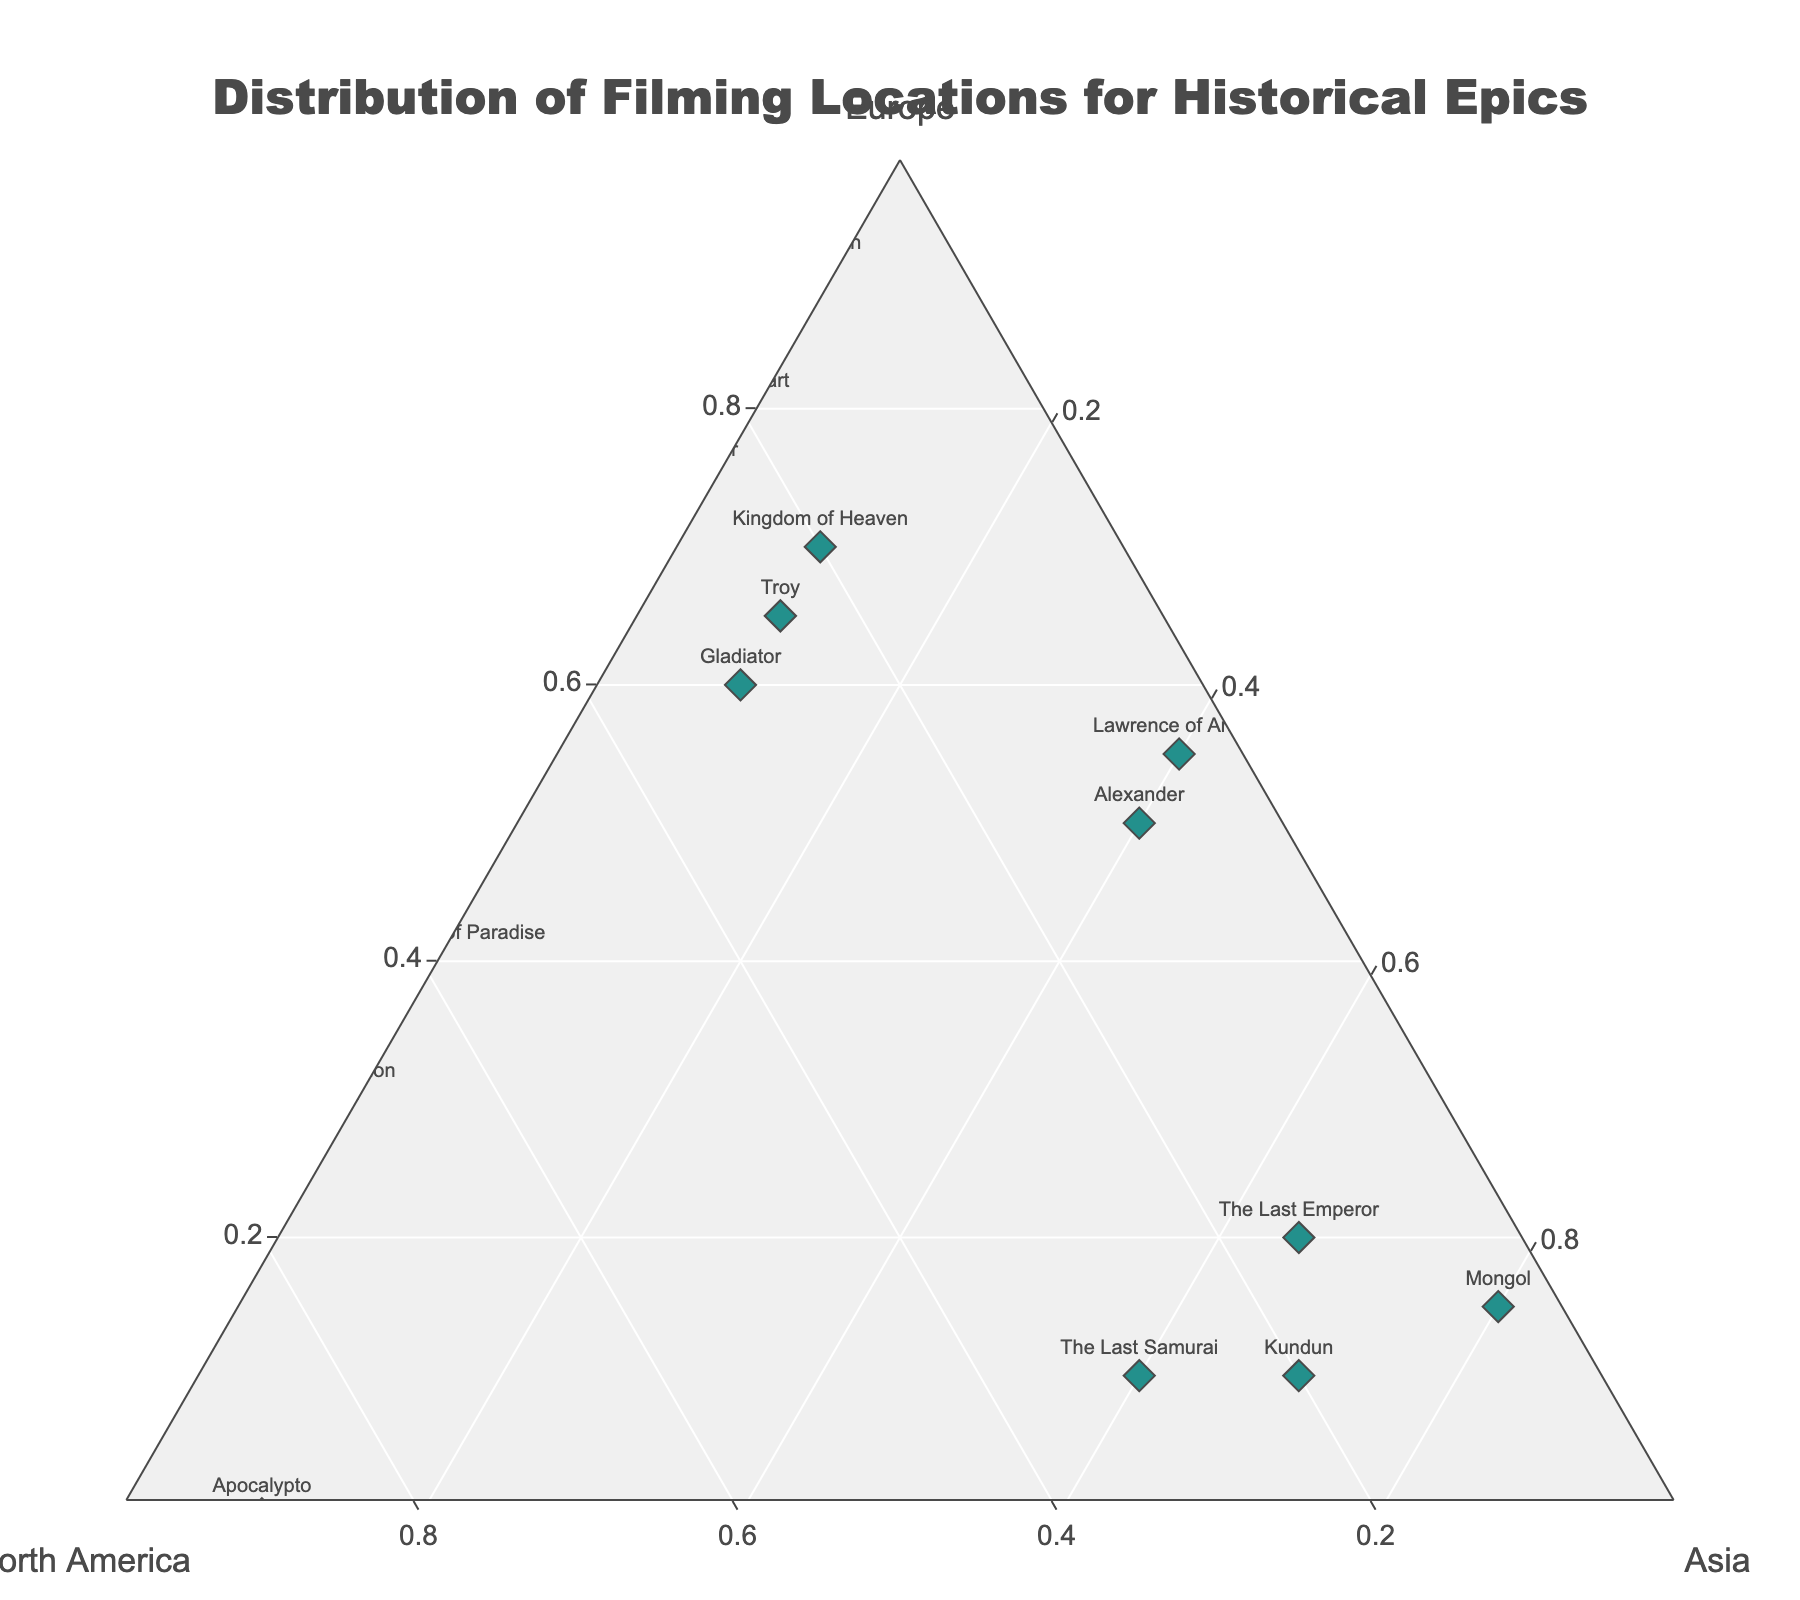what is the title of the plot? The title of the plot is prominently displayed at the top center of the figure.
Answer: "Distribution of Filming Locations for Historical Epics" How many movies have over 50% of their filming locations in Europe? Count the points located more than halfway along the Europe axis in the ternary plot.
Answer: 7 Which movie has the highest percentage of filming locations in North America? Identify the point furthest along the North America axis.
Answer: Apocalypto What percentage of Braveheart's filming locations are in North America? Locate Braveheart in the plot and check its position relative to the North America axis.
Answer: 20% Which movie has a more balanced distribution across all three continents, Alexander or Troy? Compare the positions of Alexander and Troy in the ternary plot to see which is closer to the center.
Answer: Alexander How does the distribution of Kingdom of Heaven compare to that of Lawrence of Arabia? Kingdom of Heaven is more weighted toward Europe, whereas Lawrence of Arabia has a more balanced split between Europe and Asia.
Answer: Kingdom of Heaven: Europe > North America > Asia, Lawrence of Arabia: Europe ≈ Asia > North America What is unique about the filming locations of Ben-Hur and Elizabeth? Identify the special condition for both movies related to Asia.
Answer: Both have 0% filming locations in Asia Which movies have an equal percentage distribution of filming locations in Asia? Locate and list the movies whose points are vertically aligned along the Asia axis on the plot.
Answer: Alexander, Lawrence of Arabia What is the combined percentage of European filming locations for Gladiator and Troy? Sum the percentages of European locations for Gladiator (60) and Troy (65).
Answer: 125% Which movie has a higher percentage of its total filming locations outside of Europe, The Last Samurai or Kundun? Compare the percentages outside Europe for both movies (100 - percentage in Europe). The Last Samurai has 90% non-European filming locations (100-10), and Kundun has 90% (100-10).
Answer: Both have equal percentages, 90% 